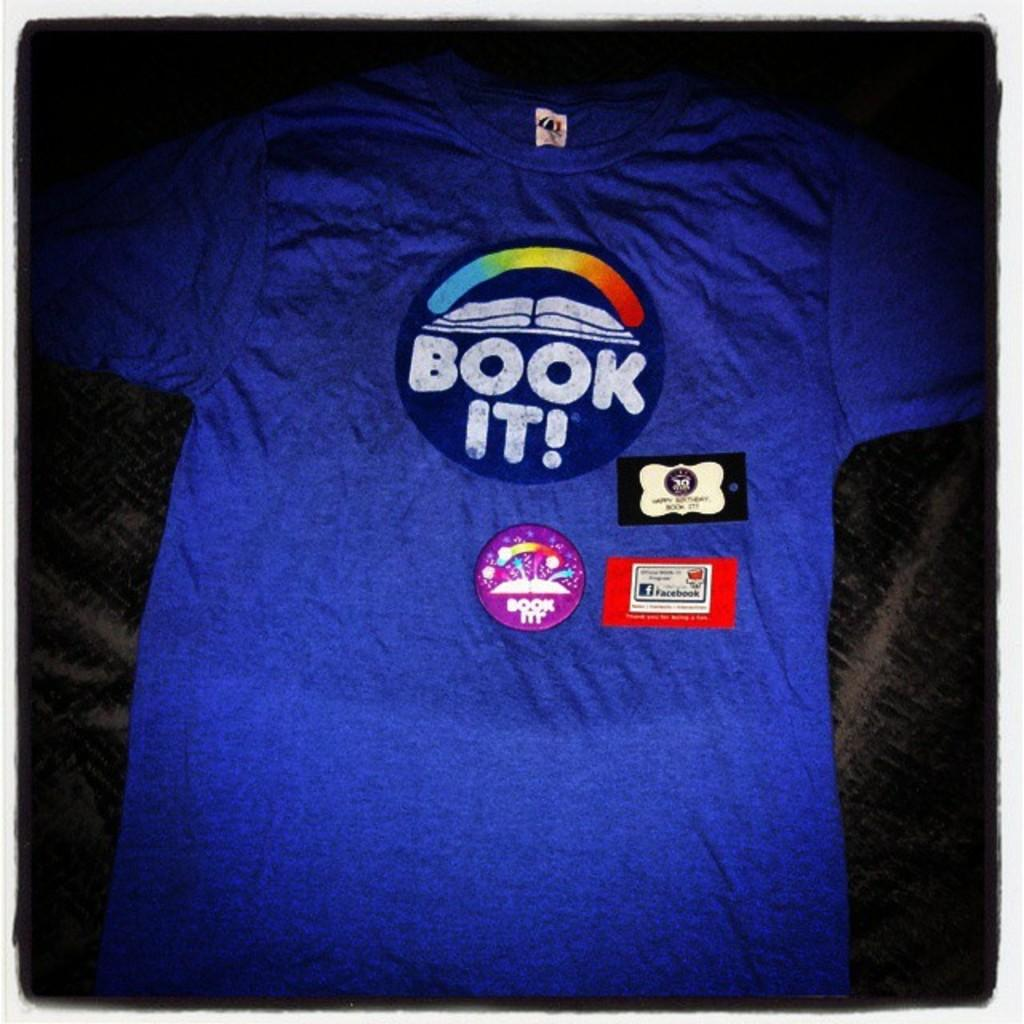<image>
Write a terse but informative summary of the picture. A blue tee shirt with the slogan book it on a circle 